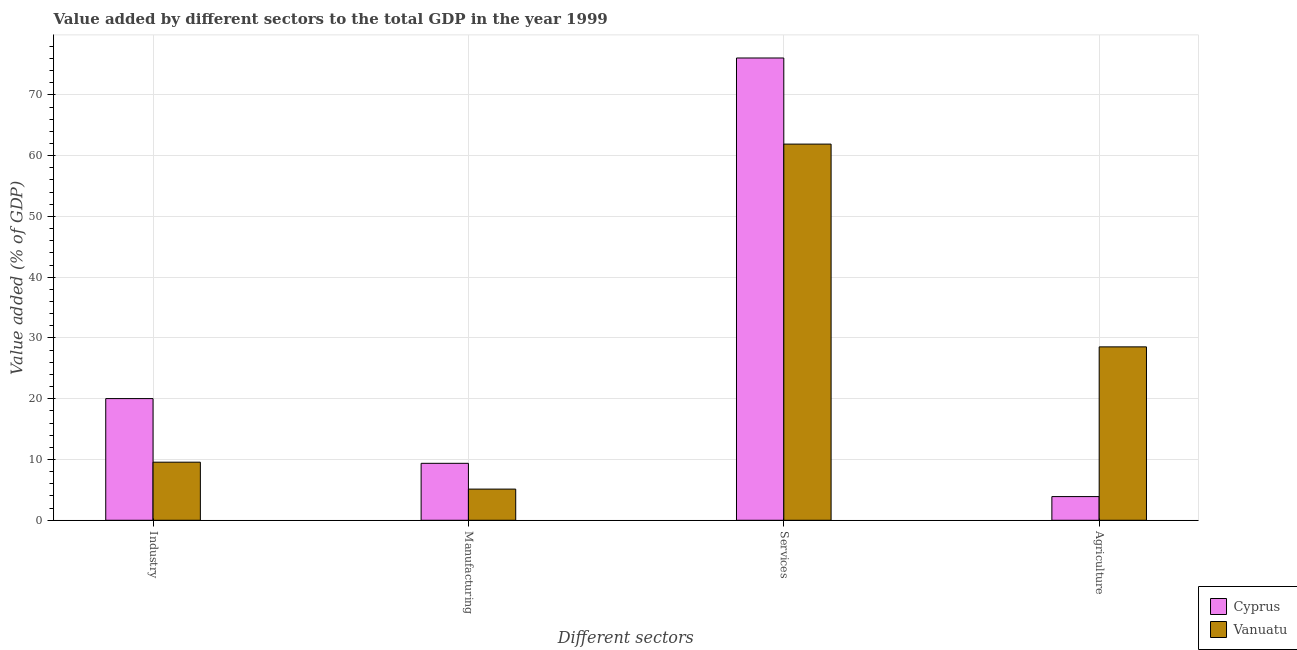Are the number of bars per tick equal to the number of legend labels?
Keep it short and to the point. Yes. How many bars are there on the 4th tick from the left?
Offer a terse response. 2. What is the label of the 1st group of bars from the left?
Your response must be concise. Industry. What is the value added by industrial sector in Cyprus?
Give a very brief answer. 20.02. Across all countries, what is the maximum value added by services sector?
Keep it short and to the point. 76.08. Across all countries, what is the minimum value added by industrial sector?
Offer a terse response. 9.56. In which country was the value added by agricultural sector maximum?
Ensure brevity in your answer.  Vanuatu. In which country was the value added by industrial sector minimum?
Your answer should be compact. Vanuatu. What is the total value added by manufacturing sector in the graph?
Keep it short and to the point. 14.5. What is the difference between the value added by agricultural sector in Vanuatu and that in Cyprus?
Make the answer very short. 24.64. What is the difference between the value added by industrial sector in Cyprus and the value added by manufacturing sector in Vanuatu?
Ensure brevity in your answer.  14.9. What is the average value added by services sector per country?
Keep it short and to the point. 68.99. What is the difference between the value added by services sector and value added by industrial sector in Vanuatu?
Provide a succinct answer. 52.35. In how many countries, is the value added by industrial sector greater than 72 %?
Give a very brief answer. 0. What is the ratio of the value added by industrial sector in Cyprus to that in Vanuatu?
Ensure brevity in your answer.  2.1. Is the value added by services sector in Vanuatu less than that in Cyprus?
Provide a succinct answer. Yes. Is the difference between the value added by agricultural sector in Vanuatu and Cyprus greater than the difference between the value added by industrial sector in Vanuatu and Cyprus?
Your answer should be very brief. Yes. What is the difference between the highest and the second highest value added by industrial sector?
Your answer should be compact. 10.47. What is the difference between the highest and the lowest value added by industrial sector?
Make the answer very short. 10.47. In how many countries, is the value added by industrial sector greater than the average value added by industrial sector taken over all countries?
Keep it short and to the point. 1. Is the sum of the value added by industrial sector in Vanuatu and Cyprus greater than the maximum value added by agricultural sector across all countries?
Keep it short and to the point. Yes. What does the 1st bar from the left in Agriculture represents?
Offer a terse response. Cyprus. What does the 1st bar from the right in Agriculture represents?
Offer a very short reply. Vanuatu. How many bars are there?
Your response must be concise. 8. Are all the bars in the graph horizontal?
Your answer should be compact. No. How many countries are there in the graph?
Give a very brief answer. 2. What is the difference between two consecutive major ticks on the Y-axis?
Keep it short and to the point. 10. Does the graph contain any zero values?
Make the answer very short. No. Does the graph contain grids?
Provide a succinct answer. Yes. What is the title of the graph?
Keep it short and to the point. Value added by different sectors to the total GDP in the year 1999. What is the label or title of the X-axis?
Provide a short and direct response. Different sectors. What is the label or title of the Y-axis?
Offer a terse response. Value added (% of GDP). What is the Value added (% of GDP) of Cyprus in Industry?
Make the answer very short. 20.02. What is the Value added (% of GDP) in Vanuatu in Industry?
Give a very brief answer. 9.56. What is the Value added (% of GDP) in Cyprus in Manufacturing?
Ensure brevity in your answer.  9.37. What is the Value added (% of GDP) in Vanuatu in Manufacturing?
Ensure brevity in your answer.  5.13. What is the Value added (% of GDP) in Cyprus in Services?
Your response must be concise. 76.08. What is the Value added (% of GDP) in Vanuatu in Services?
Ensure brevity in your answer.  61.91. What is the Value added (% of GDP) of Cyprus in Agriculture?
Offer a terse response. 3.9. What is the Value added (% of GDP) of Vanuatu in Agriculture?
Give a very brief answer. 28.54. Across all Different sectors, what is the maximum Value added (% of GDP) of Cyprus?
Make the answer very short. 76.08. Across all Different sectors, what is the maximum Value added (% of GDP) in Vanuatu?
Ensure brevity in your answer.  61.91. Across all Different sectors, what is the minimum Value added (% of GDP) of Cyprus?
Offer a terse response. 3.9. Across all Different sectors, what is the minimum Value added (% of GDP) of Vanuatu?
Your response must be concise. 5.13. What is the total Value added (% of GDP) in Cyprus in the graph?
Give a very brief answer. 109.37. What is the total Value added (% of GDP) of Vanuatu in the graph?
Ensure brevity in your answer.  105.13. What is the difference between the Value added (% of GDP) in Cyprus in Industry and that in Manufacturing?
Make the answer very short. 10.65. What is the difference between the Value added (% of GDP) in Vanuatu in Industry and that in Manufacturing?
Keep it short and to the point. 4.43. What is the difference between the Value added (% of GDP) of Cyprus in Industry and that in Services?
Provide a short and direct response. -56.05. What is the difference between the Value added (% of GDP) of Vanuatu in Industry and that in Services?
Offer a terse response. -52.35. What is the difference between the Value added (% of GDP) in Cyprus in Industry and that in Agriculture?
Give a very brief answer. 16.13. What is the difference between the Value added (% of GDP) in Vanuatu in Industry and that in Agriculture?
Give a very brief answer. -18.98. What is the difference between the Value added (% of GDP) of Cyprus in Manufacturing and that in Services?
Your answer should be very brief. -66.71. What is the difference between the Value added (% of GDP) of Vanuatu in Manufacturing and that in Services?
Your answer should be compact. -56.78. What is the difference between the Value added (% of GDP) of Cyprus in Manufacturing and that in Agriculture?
Give a very brief answer. 5.47. What is the difference between the Value added (% of GDP) in Vanuatu in Manufacturing and that in Agriculture?
Offer a terse response. -23.41. What is the difference between the Value added (% of GDP) of Cyprus in Services and that in Agriculture?
Keep it short and to the point. 72.18. What is the difference between the Value added (% of GDP) of Vanuatu in Services and that in Agriculture?
Provide a succinct answer. 33.37. What is the difference between the Value added (% of GDP) in Cyprus in Industry and the Value added (% of GDP) in Vanuatu in Manufacturing?
Your answer should be compact. 14.9. What is the difference between the Value added (% of GDP) of Cyprus in Industry and the Value added (% of GDP) of Vanuatu in Services?
Your response must be concise. -41.88. What is the difference between the Value added (% of GDP) in Cyprus in Industry and the Value added (% of GDP) in Vanuatu in Agriculture?
Give a very brief answer. -8.51. What is the difference between the Value added (% of GDP) in Cyprus in Manufacturing and the Value added (% of GDP) in Vanuatu in Services?
Your answer should be compact. -52.54. What is the difference between the Value added (% of GDP) in Cyprus in Manufacturing and the Value added (% of GDP) in Vanuatu in Agriculture?
Keep it short and to the point. -19.17. What is the difference between the Value added (% of GDP) of Cyprus in Services and the Value added (% of GDP) of Vanuatu in Agriculture?
Make the answer very short. 47.54. What is the average Value added (% of GDP) of Cyprus per Different sectors?
Your answer should be very brief. 27.34. What is the average Value added (% of GDP) of Vanuatu per Different sectors?
Your response must be concise. 26.28. What is the difference between the Value added (% of GDP) of Cyprus and Value added (% of GDP) of Vanuatu in Industry?
Keep it short and to the point. 10.47. What is the difference between the Value added (% of GDP) of Cyprus and Value added (% of GDP) of Vanuatu in Manufacturing?
Give a very brief answer. 4.24. What is the difference between the Value added (% of GDP) in Cyprus and Value added (% of GDP) in Vanuatu in Services?
Your answer should be compact. 14.17. What is the difference between the Value added (% of GDP) in Cyprus and Value added (% of GDP) in Vanuatu in Agriculture?
Give a very brief answer. -24.64. What is the ratio of the Value added (% of GDP) of Cyprus in Industry to that in Manufacturing?
Keep it short and to the point. 2.14. What is the ratio of the Value added (% of GDP) of Vanuatu in Industry to that in Manufacturing?
Make the answer very short. 1.86. What is the ratio of the Value added (% of GDP) of Cyprus in Industry to that in Services?
Your response must be concise. 0.26. What is the ratio of the Value added (% of GDP) of Vanuatu in Industry to that in Services?
Ensure brevity in your answer.  0.15. What is the ratio of the Value added (% of GDP) of Cyprus in Industry to that in Agriculture?
Provide a succinct answer. 5.14. What is the ratio of the Value added (% of GDP) of Vanuatu in Industry to that in Agriculture?
Your response must be concise. 0.34. What is the ratio of the Value added (% of GDP) of Cyprus in Manufacturing to that in Services?
Offer a very short reply. 0.12. What is the ratio of the Value added (% of GDP) of Vanuatu in Manufacturing to that in Services?
Make the answer very short. 0.08. What is the ratio of the Value added (% of GDP) of Cyprus in Manufacturing to that in Agriculture?
Offer a very short reply. 2.4. What is the ratio of the Value added (% of GDP) of Vanuatu in Manufacturing to that in Agriculture?
Give a very brief answer. 0.18. What is the ratio of the Value added (% of GDP) in Cyprus in Services to that in Agriculture?
Offer a terse response. 19.52. What is the ratio of the Value added (% of GDP) in Vanuatu in Services to that in Agriculture?
Your response must be concise. 2.17. What is the difference between the highest and the second highest Value added (% of GDP) in Cyprus?
Ensure brevity in your answer.  56.05. What is the difference between the highest and the second highest Value added (% of GDP) of Vanuatu?
Provide a succinct answer. 33.37. What is the difference between the highest and the lowest Value added (% of GDP) in Cyprus?
Your response must be concise. 72.18. What is the difference between the highest and the lowest Value added (% of GDP) in Vanuatu?
Offer a terse response. 56.78. 